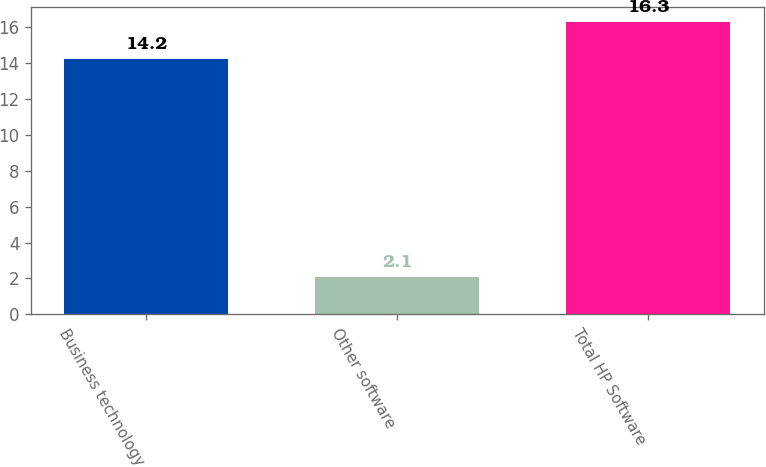Convert chart to OTSL. <chart><loc_0><loc_0><loc_500><loc_500><bar_chart><fcel>Business technology<fcel>Other software<fcel>Total HP Software<nl><fcel>14.2<fcel>2.1<fcel>16.3<nl></chart> 